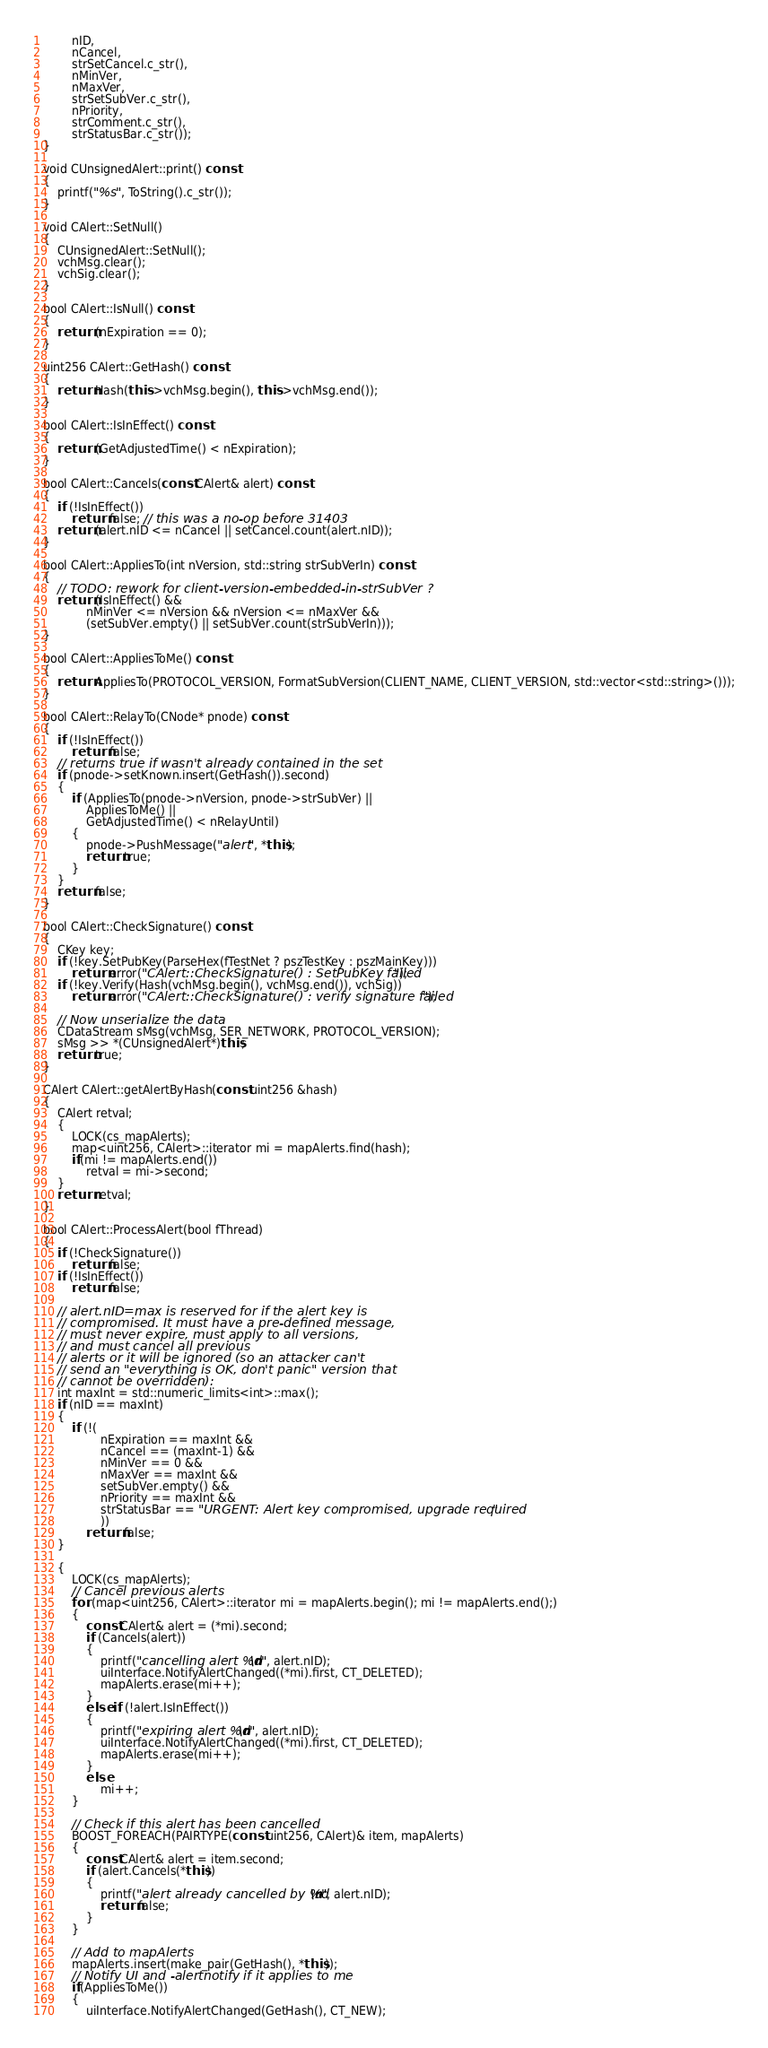<code> <loc_0><loc_0><loc_500><loc_500><_C++_>        nID,
        nCancel,
        strSetCancel.c_str(),
        nMinVer,
        nMaxVer,
        strSetSubVer.c_str(),
        nPriority,
        strComment.c_str(),
        strStatusBar.c_str());
}

void CUnsignedAlert::print() const
{
    printf("%s", ToString().c_str());
}

void CAlert::SetNull()
{
    CUnsignedAlert::SetNull();
    vchMsg.clear();
    vchSig.clear();
}

bool CAlert::IsNull() const
{
    return (nExpiration == 0);
}

uint256 CAlert::GetHash() const
{
    return Hash(this->vchMsg.begin(), this->vchMsg.end());
}

bool CAlert::IsInEffect() const
{
    return (GetAdjustedTime() < nExpiration);
}

bool CAlert::Cancels(const CAlert& alert) const
{
    if (!IsInEffect())
        return false; // this was a no-op before 31403
    return (alert.nID <= nCancel || setCancel.count(alert.nID));
}

bool CAlert::AppliesTo(int nVersion, std::string strSubVerIn) const
{
    // TODO: rework for client-version-embedded-in-strSubVer ?
    return (IsInEffect() &&
            nMinVer <= nVersion && nVersion <= nMaxVer &&
            (setSubVer.empty() || setSubVer.count(strSubVerIn)));
}

bool CAlert::AppliesToMe() const
{
    return AppliesTo(PROTOCOL_VERSION, FormatSubVersion(CLIENT_NAME, CLIENT_VERSION, std::vector<std::string>()));
}

bool CAlert::RelayTo(CNode* pnode) const
{
    if (!IsInEffect())
        return false;
    // returns true if wasn't already contained in the set
    if (pnode->setKnown.insert(GetHash()).second)
    {
        if (AppliesTo(pnode->nVersion, pnode->strSubVer) ||
            AppliesToMe() ||
            GetAdjustedTime() < nRelayUntil)
        {
            pnode->PushMessage("alert", *this);
            return true;
        }
    }
    return false;
}

bool CAlert::CheckSignature() const
{
    CKey key;
    if (!key.SetPubKey(ParseHex(fTestNet ? pszTestKey : pszMainKey)))
        return error("CAlert::CheckSignature() : SetPubKey failed");
    if (!key.Verify(Hash(vchMsg.begin(), vchMsg.end()), vchSig))
        return error("CAlert::CheckSignature() : verify signature failed");

    // Now unserialize the data
    CDataStream sMsg(vchMsg, SER_NETWORK, PROTOCOL_VERSION);
    sMsg >> *(CUnsignedAlert*)this;
    return true;
}

CAlert CAlert::getAlertByHash(const uint256 &hash)
{
    CAlert retval;
    {
        LOCK(cs_mapAlerts);
        map<uint256, CAlert>::iterator mi = mapAlerts.find(hash);
        if(mi != mapAlerts.end())
            retval = mi->second;
    }
    return retval;
}

bool CAlert::ProcessAlert(bool fThread)
{
    if (!CheckSignature())
        return false;
    if (!IsInEffect())
        return false;

    // alert.nID=max is reserved for if the alert key is
    // compromised. It must have a pre-defined message,
    // must never expire, must apply to all versions,
    // and must cancel all previous
    // alerts or it will be ignored (so an attacker can't
    // send an "everything is OK, don't panic" version that
    // cannot be overridden):
    int maxInt = std::numeric_limits<int>::max();
    if (nID == maxInt)
    {
        if (!(
                nExpiration == maxInt &&
                nCancel == (maxInt-1) &&
                nMinVer == 0 &&
                nMaxVer == maxInt &&
                setSubVer.empty() &&
                nPriority == maxInt &&
                strStatusBar == "URGENT: Alert key compromised, upgrade required"
                ))
            return false;
    }

    {
        LOCK(cs_mapAlerts);
        // Cancel previous alerts
        for (map<uint256, CAlert>::iterator mi = mapAlerts.begin(); mi != mapAlerts.end();)
        {
            const CAlert& alert = (*mi).second;
            if (Cancels(alert))
            {
                printf("cancelling alert %d\n", alert.nID);
                uiInterface.NotifyAlertChanged((*mi).first, CT_DELETED);
                mapAlerts.erase(mi++);
            }
            else if (!alert.IsInEffect())
            {
                printf("expiring alert %d\n", alert.nID);
                uiInterface.NotifyAlertChanged((*mi).first, CT_DELETED);
                mapAlerts.erase(mi++);
            }
            else
                mi++;
        }

        // Check if this alert has been cancelled
        BOOST_FOREACH(PAIRTYPE(const uint256, CAlert)& item, mapAlerts)
        {
            const CAlert& alert = item.second;
            if (alert.Cancels(*this))
            {
                printf("alert already cancelled by %d\n", alert.nID);
                return false;
            }
        }

        // Add to mapAlerts
        mapAlerts.insert(make_pair(GetHash(), *this));
        // Notify UI and -alertnotify if it applies to me
        if(AppliesToMe())
        {
            uiInterface.NotifyAlertChanged(GetHash(), CT_NEW);</code> 